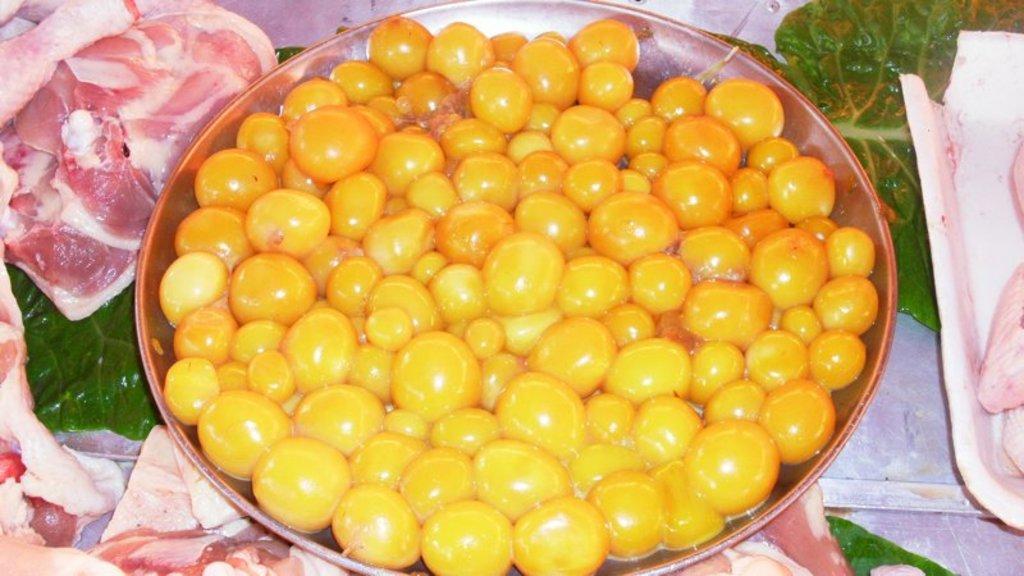Please provide a concise description of this image. In this picture, there is some food in the plate. On both the sides of the image, there is some meat in the trays. 